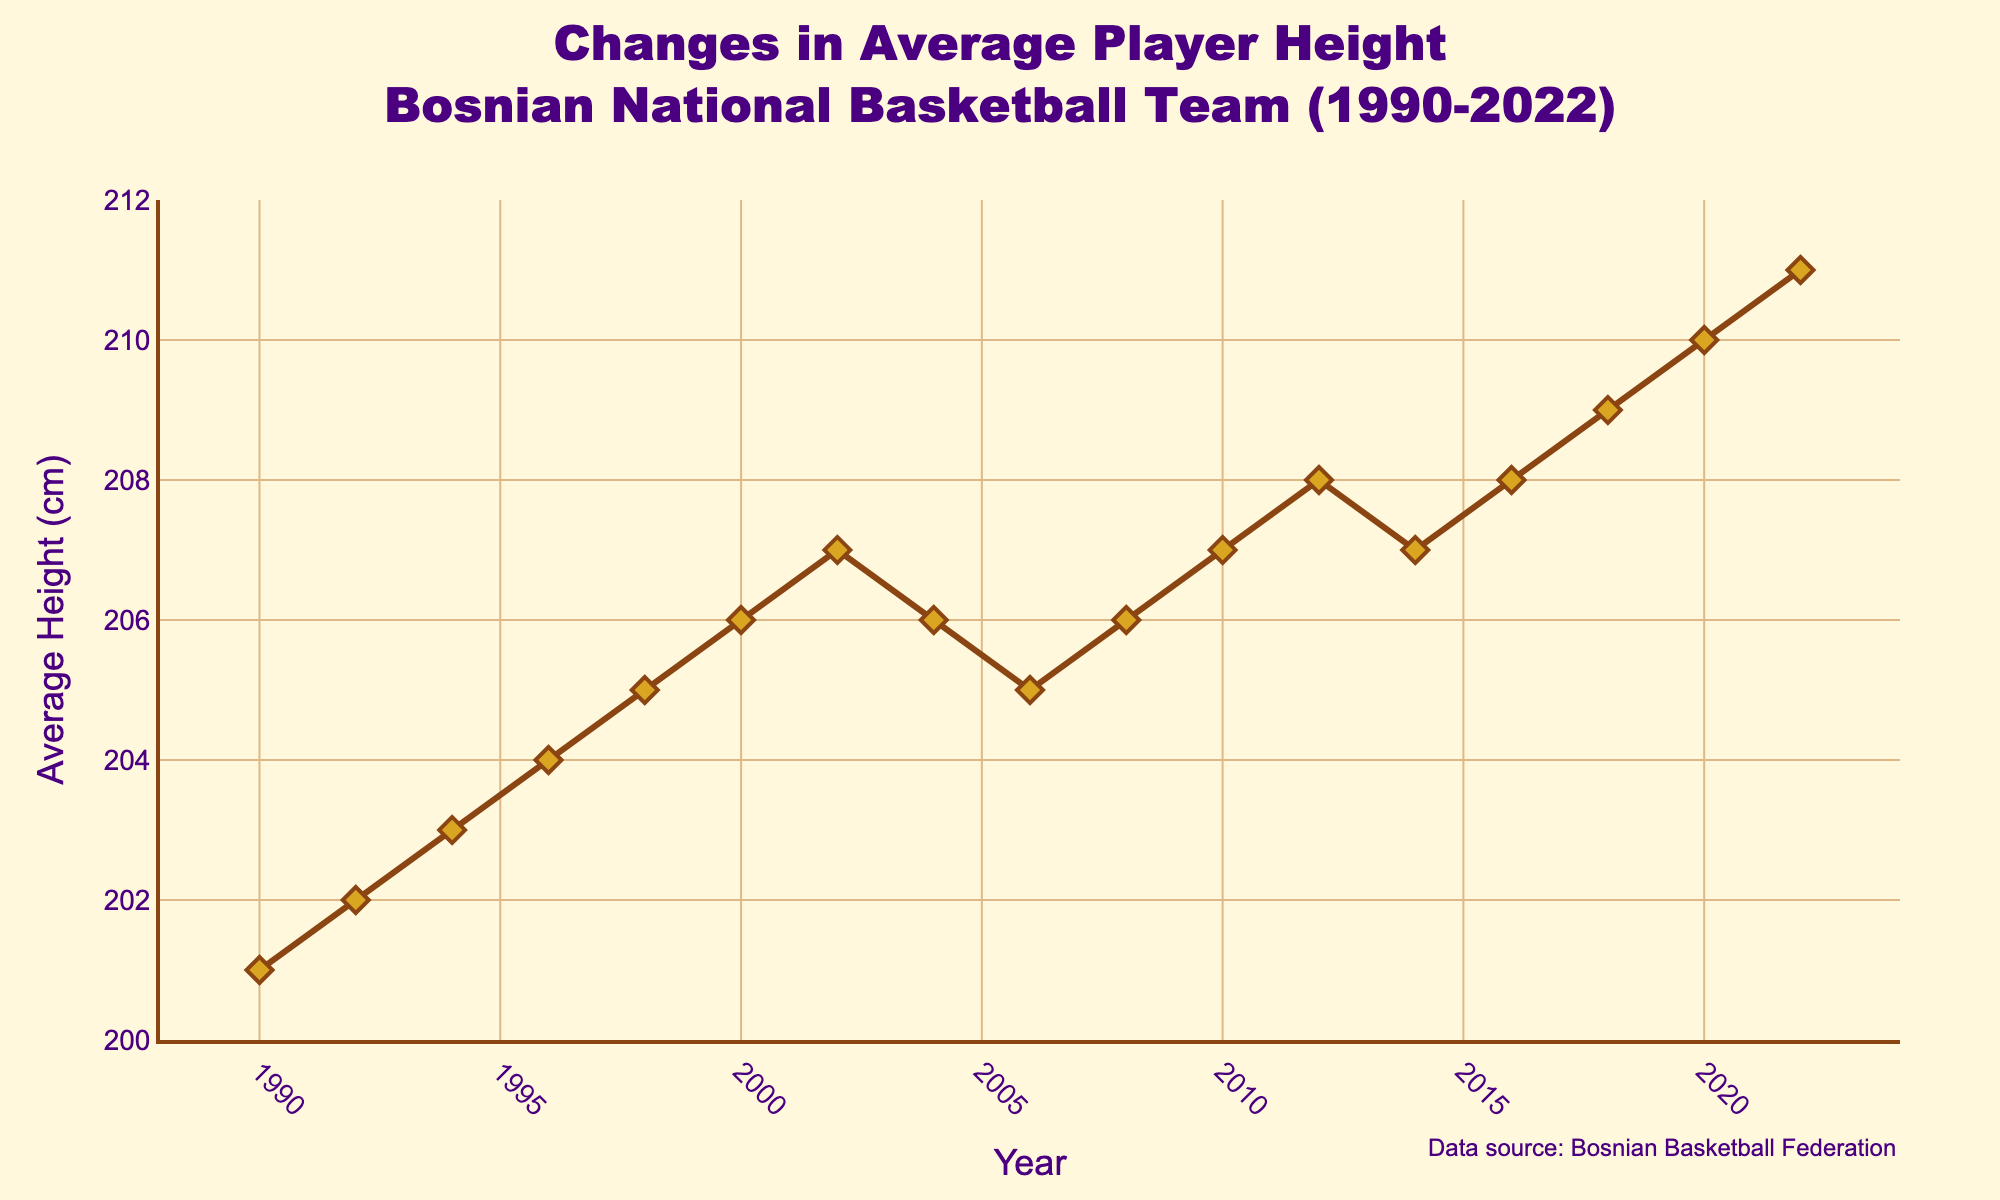What is the average player height in 2000? Check the y-axis value corresponding to the year 2000 on the x-axis. The value is 206 cm, which is the average player height in 2000.
Answer: 206 cm Which year had the highest average player height? Find the peak of the line on the graph. The highest point is at the year 2022 with an average player height of 211 cm.
Answer: 2022 How did average player height change from 1990 to 2022? Subtract the average height in 1990 from the average height in 2022 (211 cm - 201 cm). The change is 10 cm.
Answer: Increased by 10 cm During which period did the average player height first decrease, then increase again? Look for the years where the line graph descends and then ascends. The period is from 2002 (207 cm) to 2006 (205 cm) and then increases again from 2006 to 2010.
Answer: 2002-2010 What is the difference in average player height between 2010 and 2018? Subtract the average height in 2010 from that in 2018 (209 cm - 207 cm). The difference is 2 cm.
Answer: 2 cm Which years had an average player height of 207 cm? Identify the years corresponding to the 207 cm mark on the y-axis. The years are 2002, 2010, and 2014.
Answer: 2002, 2010, 2014 In which year did the average player height decrease compared to the previous year the most? Compare year-on-year decreases. The largest decrease is from 2002 (207 cm) to 2004 (206 cm). The change is 1 cm.
Answer: 2002 to 2004 What is the average of the average player heights from 1990 to 2000? Sum the heights from 1990 to 2000 (201+202+203+204+205+206) = 1221. Divide by the number of years (6). The average height is 1221/6 = 203.5 cm.
Answer: 203.5 cm What visual elements highlight the years at which average player height was exceptionally low or high? Examine the symbols and line properties. The graph uses diamond markers and lines to highlight each data point, where significant peaks and troughs stand out visually.
Answer: Diamond markers and line peaks/troughs Which period had a continuous increase in average player height without any decrease? Find the period in which the line continuously ascends without any dips. The period is from 1990 (201 cm) to 2002 (207 cm).
Answer: 1990-2002 